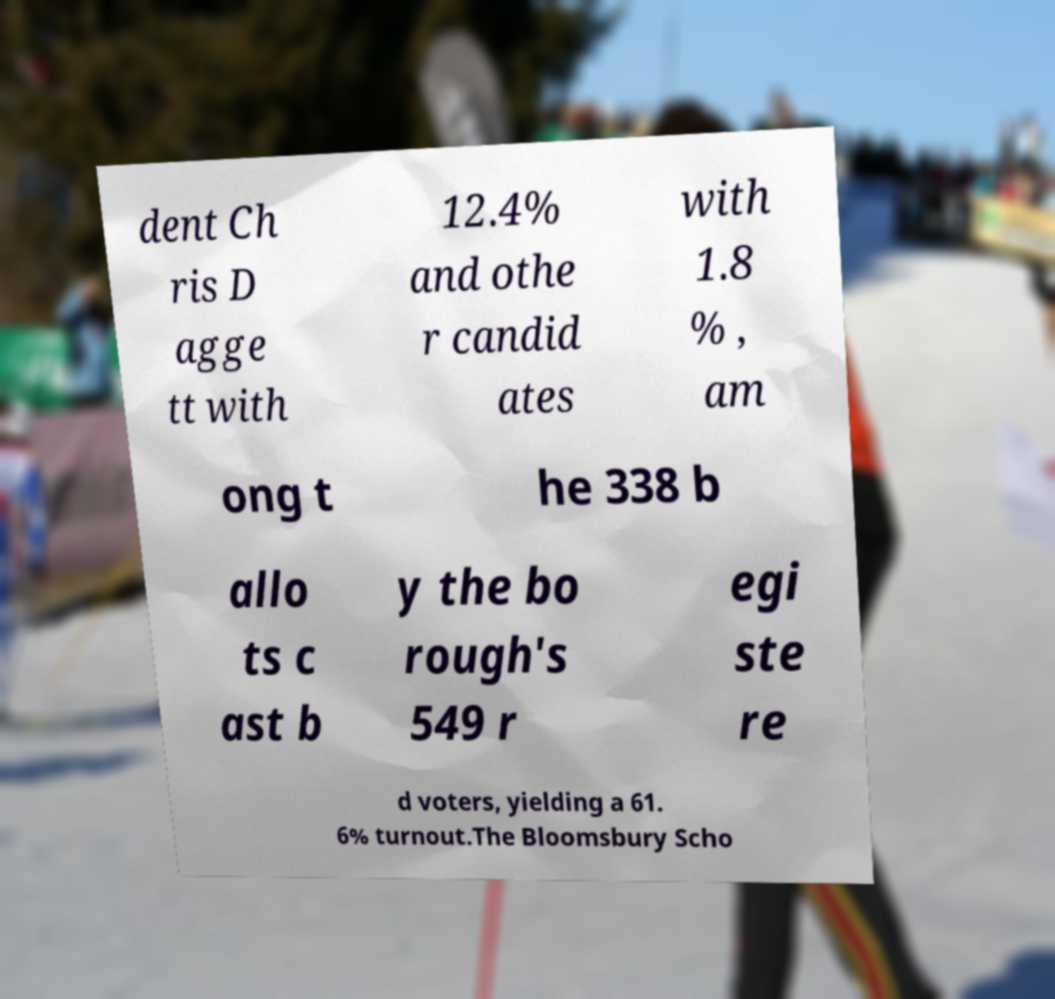For documentation purposes, I need the text within this image transcribed. Could you provide that? dent Ch ris D agge tt with 12.4% and othe r candid ates with 1.8 % , am ong t he 338 b allo ts c ast b y the bo rough's 549 r egi ste re d voters, yielding a 61. 6% turnout.The Bloomsbury Scho 